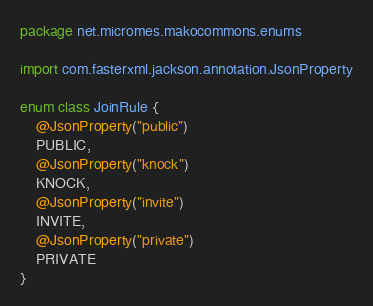<code> <loc_0><loc_0><loc_500><loc_500><_Kotlin_>package net.micromes.makocommons.enums

import com.fasterxml.jackson.annotation.JsonProperty

enum class JoinRule {
    @JsonProperty("public")
    PUBLIC,
    @JsonProperty("knock")
    KNOCK,
    @JsonProperty("invite")
    INVITE,
    @JsonProperty("private")
    PRIVATE
}</code> 